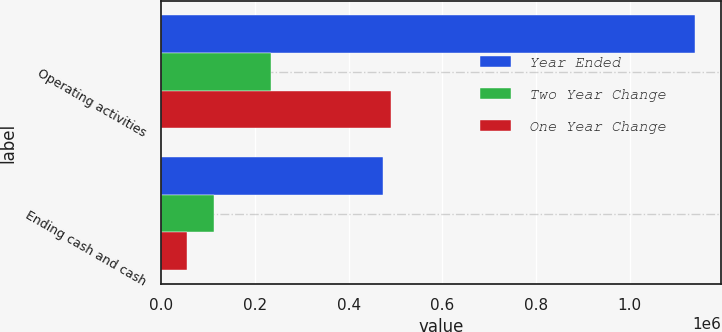Convert chart. <chart><loc_0><loc_0><loc_500><loc_500><stacked_bar_chart><ecel><fcel>Operating activities<fcel>Ending cash and cash<nl><fcel>Year Ended<fcel>1.13867e+06<fcel>473726<nl><fcel>Two Year Change<fcel>234798<fcel>112818<nl><fcel>One Year Change<fcel>490025<fcel>54348<nl></chart> 